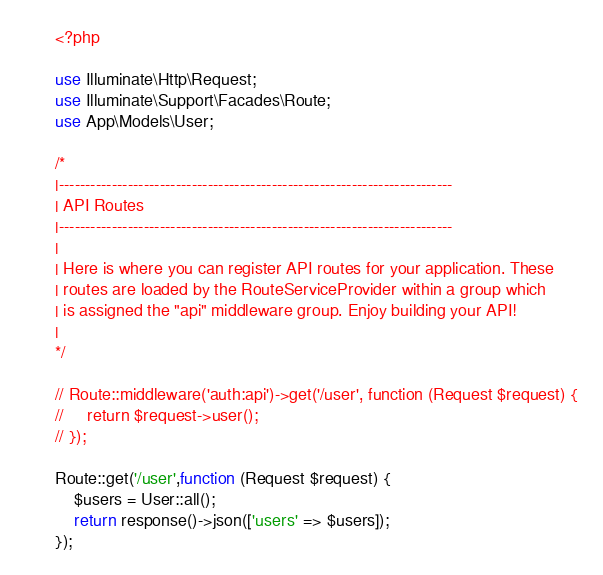<code> <loc_0><loc_0><loc_500><loc_500><_PHP_><?php

use Illuminate\Http\Request;
use Illuminate\Support\Facades\Route;
use App\Models\User;

/*
|--------------------------------------------------------------------------
| API Routes
|--------------------------------------------------------------------------
|
| Here is where you can register API routes for your application. These
| routes are loaded by the RouteServiceProvider within a group which
| is assigned the "api" middleware group. Enjoy building your API!
|
*/

// Route::middleware('auth:api')->get('/user', function (Request $request) {
//     return $request->user();
// });

Route::get('/user',function (Request $request) {
    $users = User::all();
    return response()->json(['users' => $users]);
});</code> 